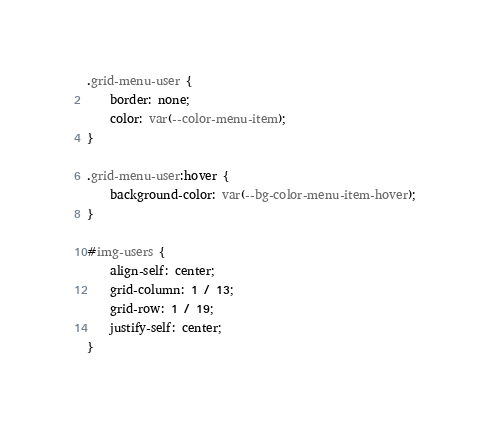<code> <loc_0><loc_0><loc_500><loc_500><_CSS_>
.grid-menu-user {
    border: none;
    color: var(--color-menu-item);
}

.grid-menu-user:hover {
    background-color: var(--bg-color-menu-item-hover);
}

#img-users {
    align-self: center;
    grid-column: 1 / 13;
    grid-row: 1 / 19;
    justify-self: center;
}
</code> 